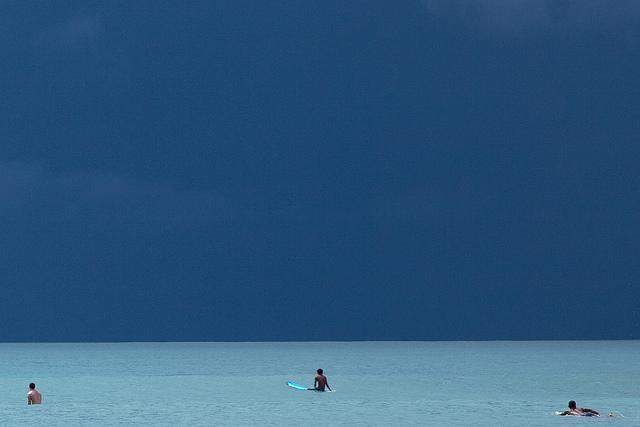How many people are in the water?
Give a very brief answer. 3. How many cows are facing the ocean?
Give a very brief answer. 0. 